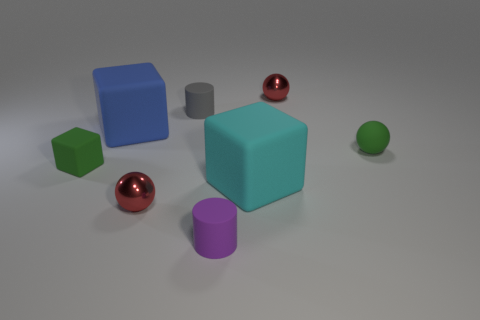Add 2 tiny purple shiny cylinders. How many objects exist? 10 Subtract all red spheres. How many spheres are left? 1 Add 4 large cyan rubber spheres. How many large cyan rubber spheres exist? 4 Subtract all green balls. How many balls are left? 2 Subtract 0 yellow cylinders. How many objects are left? 8 Subtract all cubes. How many objects are left? 5 Subtract 1 cubes. How many cubes are left? 2 Subtract all red spheres. Subtract all yellow cubes. How many spheres are left? 1 Subtract all cyan cubes. How many cyan cylinders are left? 0 Subtract all large red matte cubes. Subtract all blue rubber objects. How many objects are left? 7 